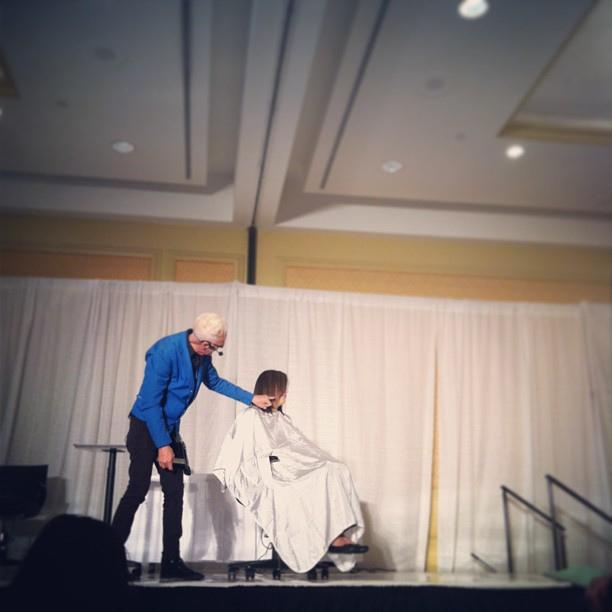What is the woman receiving on the stage? haircut 